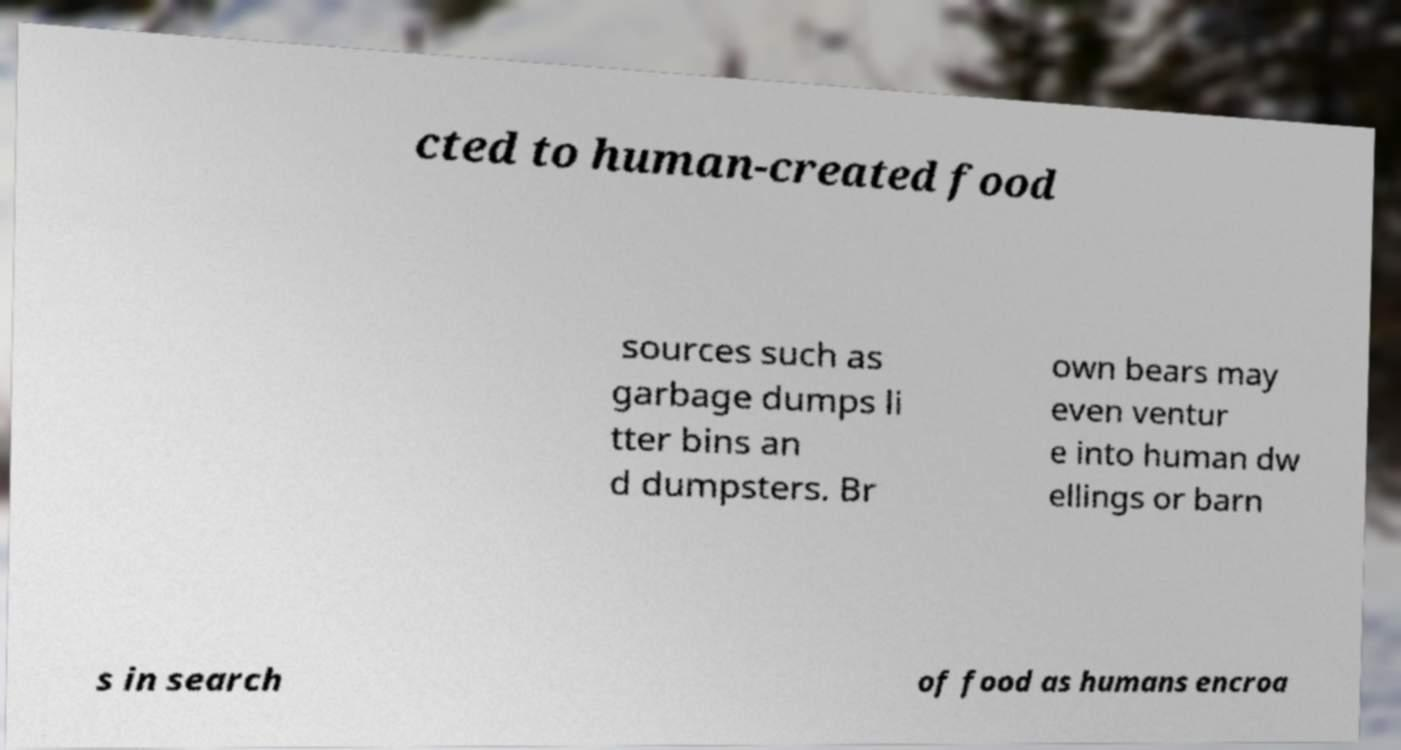There's text embedded in this image that I need extracted. Can you transcribe it verbatim? cted to human-created food sources such as garbage dumps li tter bins an d dumpsters. Br own bears may even ventur e into human dw ellings or barn s in search of food as humans encroa 